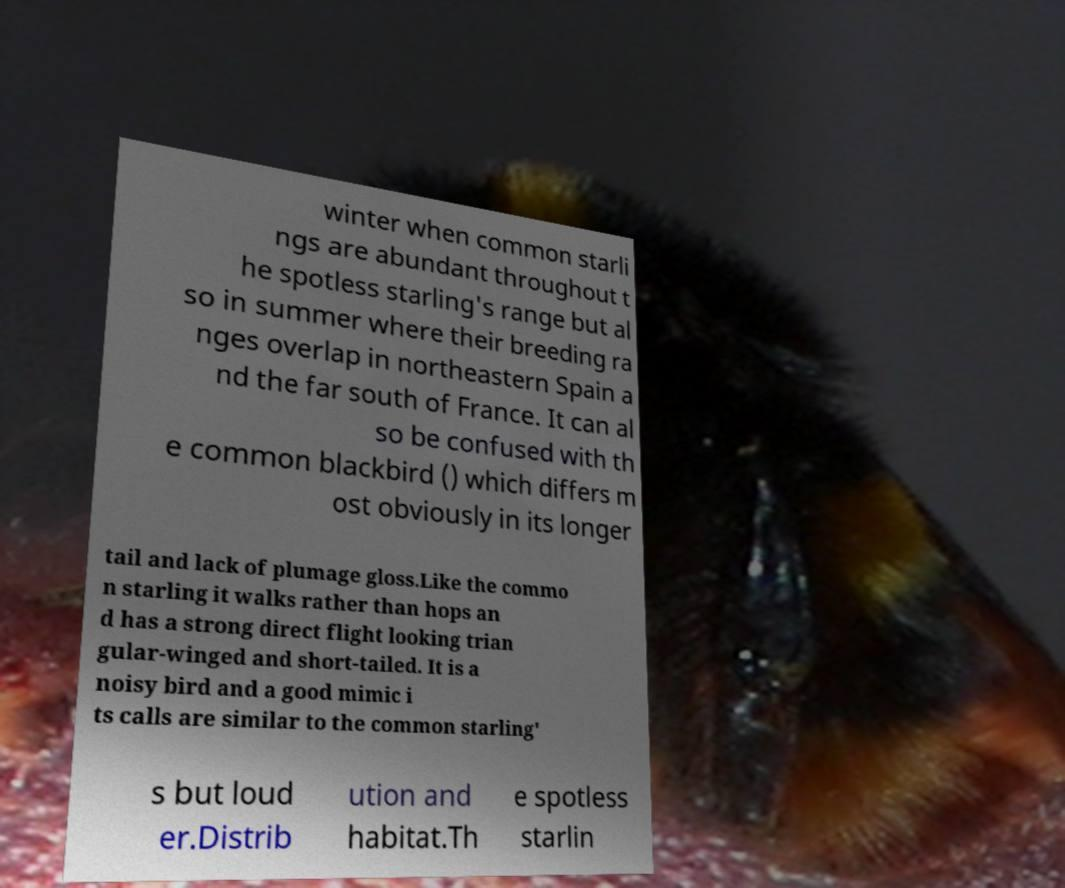I need the written content from this picture converted into text. Can you do that? winter when common starli ngs are abundant throughout t he spotless starling's range but al so in summer where their breeding ra nges overlap in northeastern Spain a nd the far south of France. It can al so be confused with th e common blackbird () which differs m ost obviously in its longer tail and lack of plumage gloss.Like the commo n starling it walks rather than hops an d has a strong direct flight looking trian gular-winged and short-tailed. It is a noisy bird and a good mimic i ts calls are similar to the common starling' s but loud er.Distrib ution and habitat.Th e spotless starlin 